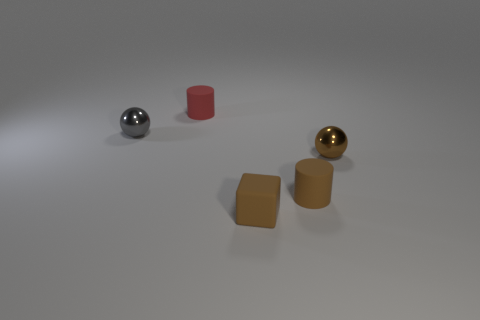What color is the block?
Keep it short and to the point. Brown. The other small ball that is the same material as the tiny gray sphere is what color?
Your answer should be very brief. Brown. How many small gray objects have the same material as the brown cylinder?
Provide a short and direct response. 0. How many small objects are behind the brown matte block?
Offer a very short reply. 4. Does the small sphere that is left of the rubber block have the same material as the small cylinder behind the small brown shiny object?
Your answer should be very brief. No. Is the number of cubes to the right of the tiny brown sphere greater than the number of matte cylinders in front of the brown matte block?
Keep it short and to the point. No. What material is the cylinder that is the same color as the matte block?
Your answer should be very brief. Rubber. Are there any other things that are the same shape as the tiny gray shiny thing?
Offer a terse response. Yes. There is a small brown object that is both in front of the brown metal object and behind the small rubber cube; what is its material?
Offer a terse response. Rubber. Do the small brown cylinder and the sphere that is right of the tiny red rubber cylinder have the same material?
Offer a very short reply. No. 